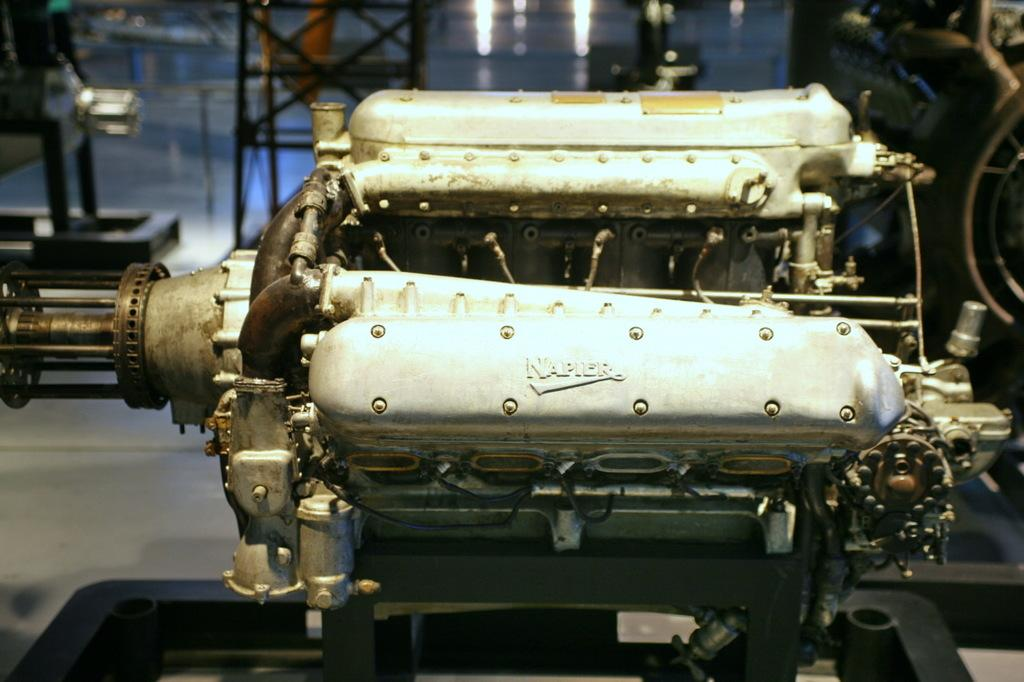What is the main subject in the center of the image? There is a machine in the center of the image. What can be seen on the machine? There is text written on the machine. What is visible in the background of the image? There is a stand in the background of the image. What is the color of the stand? The stand is black in color. What else can be seen on the right side of the image? There is another machine on the right side of the image. What date is circled on the calendar in the image? There is no calendar present in the image. What type of education can be seen being provided in the image? There is no educational activity depicted in the image. 